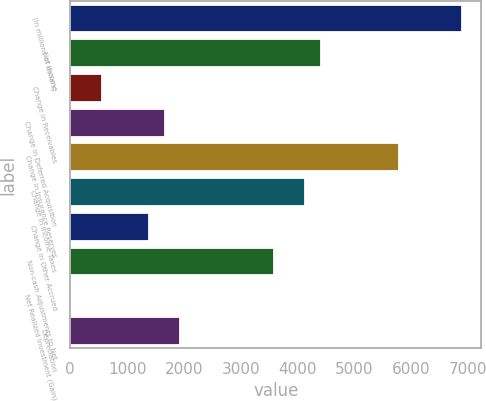Convert chart to OTSL. <chart><loc_0><loc_0><loc_500><loc_500><bar_chart><fcel>(in millions of dollars)<fcel>Net Income<fcel>Change in Receivables<fcel>Change in Deferred Acquisition<fcel>Change in Insurance Reserves<fcel>Change in Income Taxes<fcel>Change in Other Accrued<fcel>Non-cash Adjustments to Net<fcel>Net Realized Investment (Gain)<fcel>Depreciation<nl><fcel>6892.9<fcel>4413.22<fcel>555.94<fcel>1658.02<fcel>5790.82<fcel>4137.7<fcel>1382.5<fcel>3586.66<fcel>4.9<fcel>1933.54<nl></chart> 